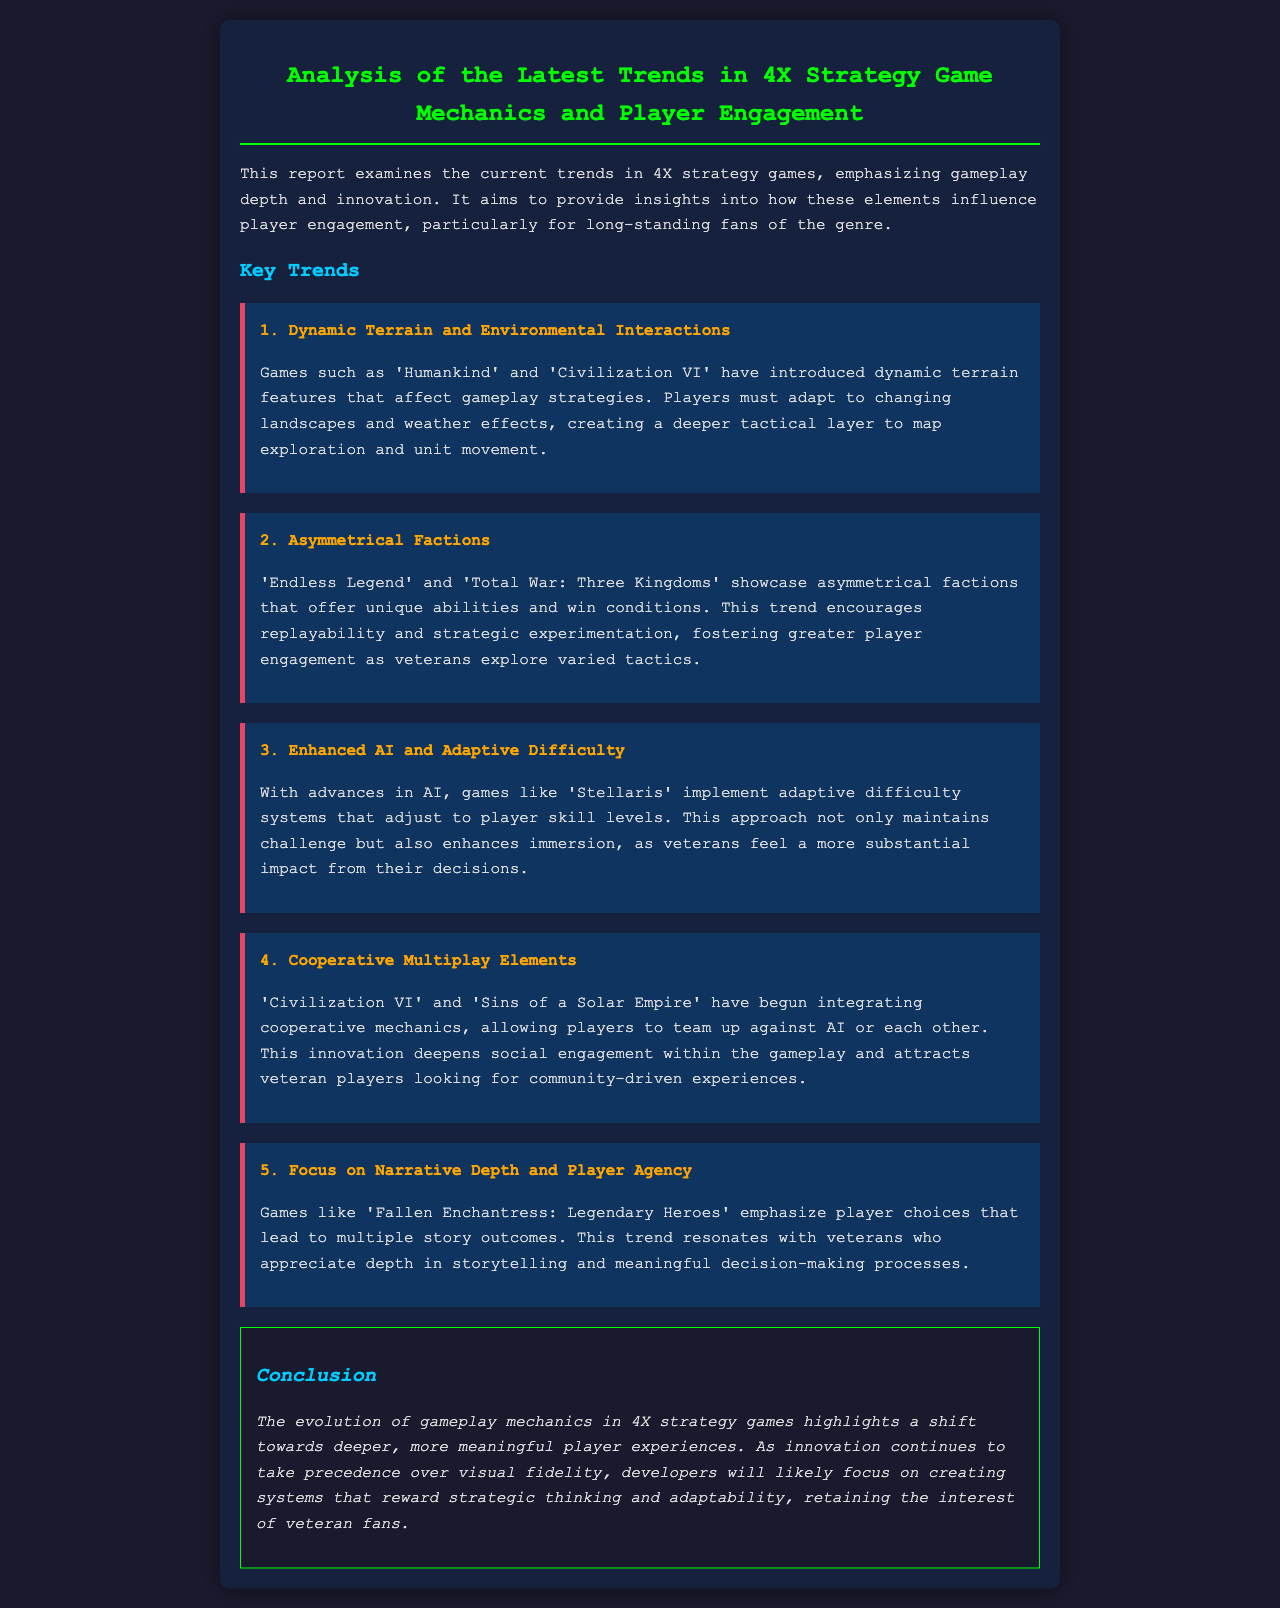What game introduced dynamic terrain features? The report mentions 'Humankind' and 'Civilization VI' as games that have introduced dynamic terrain features affecting gameplay strategies.
Answer: Humankind, Civilization VI Which trend emphasizes player choices leading to multiple story outcomes? The report highlights the trend focused on narrative depth and player agency, particularly in 'Fallen Enchantress: Legendary Heroes'.
Answer: Focus on Narrative Depth and Player Agency What game uses adaptive difficulty systems? 'Stellaris' is cited as a game that implements adaptive difficulty systems that adjust to player skill levels.
Answer: Stellaris How many key trends are discussed in the report? The report describes five key trends related to 4X strategy games and player engagement.
Answer: Five What is the primary benefit of asymmetrical factions? Asymmetrical factions are linked to increased replayability and strategic experimentation, as veterans explore varied tactics.
Answer: Replayability and strategic experimentation Which games are mentioned for integrating cooperative mechanics? 'Civilization VI' and 'Sins of a Solar Empire' are stated to have begun integrating cooperative mechanics in their gameplay.
Answer: Civilization VI, Sins of a Solar Empire What do developers likely focus on, according to the conclusion? Developers are likely to concentrate on creating systems that reward strategic thinking and adaptability, as noted in the conclusion.
Answer: Strategic thinking and adaptability What color is used for the main heading? The main heading is styled with a green color as stated in the document.
Answer: Green 